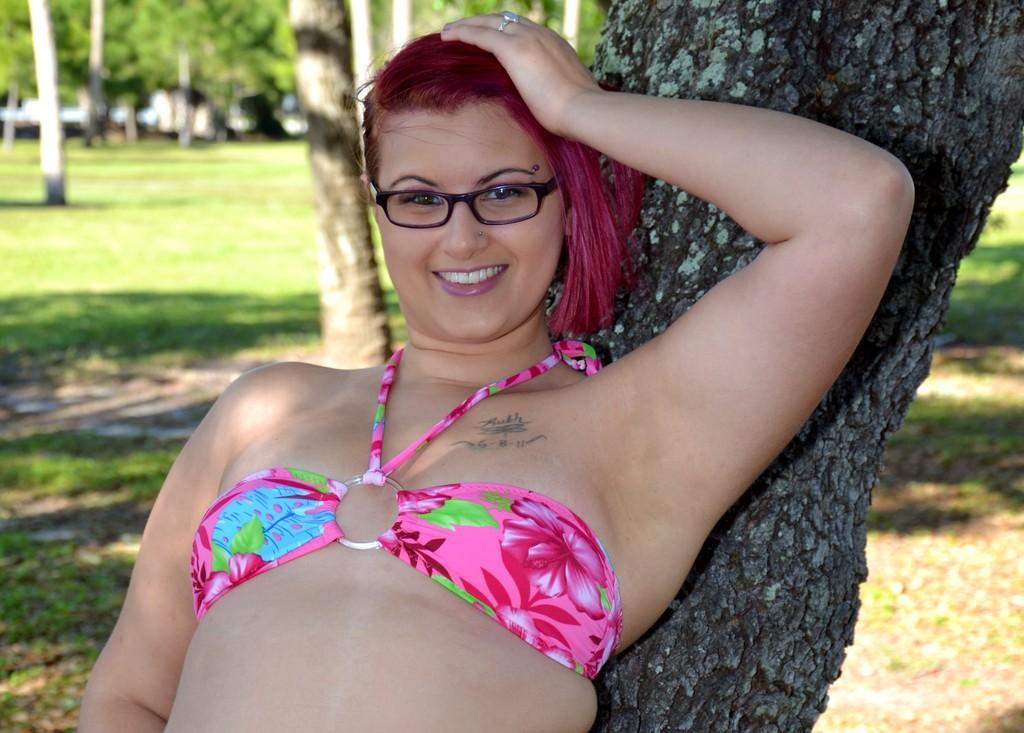Could you give a brief overview of what you see in this image? In the picture I can see a woman wearing pink color bikini and spectacles is lying on the tree trunk and smiling. Here we can see a tattoo on her chest. The background of the image is blurred, where we can see the grass and trees. 